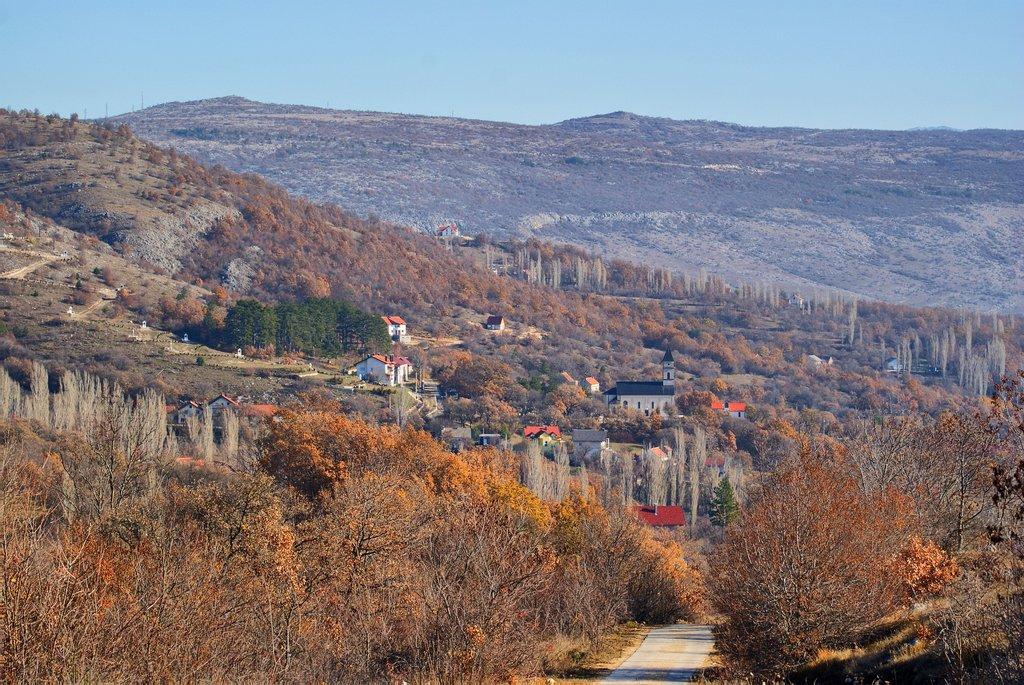How would you summarize this image in a sentence or two? In This image at the bottom there are some trees and houses and in the background there are some mountains, on the top of the image there is sky. 